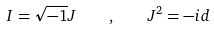<formula> <loc_0><loc_0><loc_500><loc_500>I = \sqrt { - 1 } J \quad , \quad J ^ { 2 } = - i d</formula> 